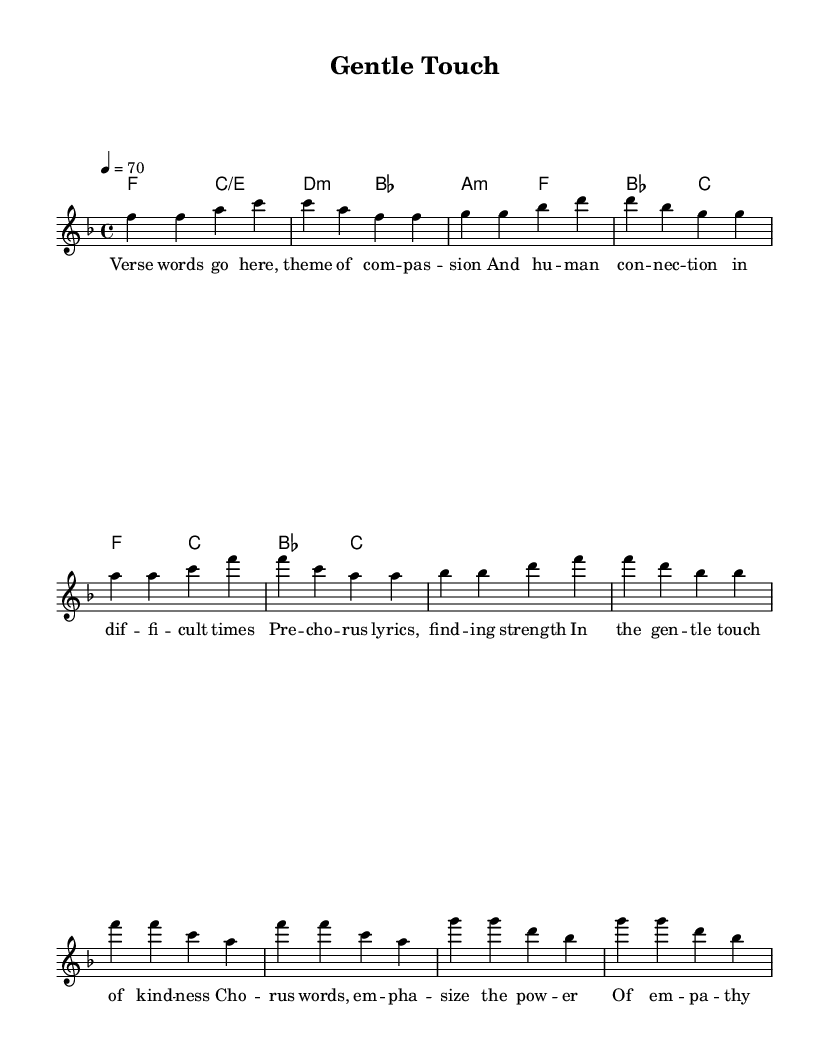What is the key signature of this music? The key signature indicated in the music is F major, which has one flat (B). This can be found in the first line of the score under the global settings.
Answer: F major What is the time signature of this music? The time signature shown in the score is 4/4, which is indicated on the first line of the global settings. This means there are four beats in each measure and the quarter note gets one beat.
Answer: 4/4 What is the tempo marking of this music? The tempo marking in the global settings states "4 = 70," meaning the quarter note is played at a speed of 70 beats per minute. This indicates a moderate tempo for the piece.
Answer: 70 How many measures are in the melody section? Counting the measures in the melody, there are a total of 8 measures. This can be verified by counting the groupings of notes separated by vertical lines (bar lines) in the melody section.
Answer: 8 What are the lyrics' main themes? The lyrics of the song emphasize themes of compassion and human connection during difficult times. This can be understood by reading the placeholder lyrics which explicitly mention these themes.
Answer: Compassion and connection What chords are used in the pre-chorus? The chords listed in the pre-chorus section include A minor and F major. This can be seen in the chord mode part of the score where these specific chords are indicated for that segment.
Answer: A minor, F major Which section of the song highlights the power of empathy? The chorus section specifically emphasizes the power of empathy and love, according to the placeholder lyrics provided. By analyzing the lyrics, we can see that this is where the main message is delivered.
Answer: Chorus 